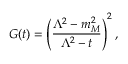Convert formula to latex. <formula><loc_0><loc_0><loc_500><loc_500>G ( t ) = \left ( { \frac { \Lambda ^ { 2 } - m _ { M } ^ { 2 } } { \Lambda ^ { 2 } - t } } \right ) ^ { 2 } ,</formula> 